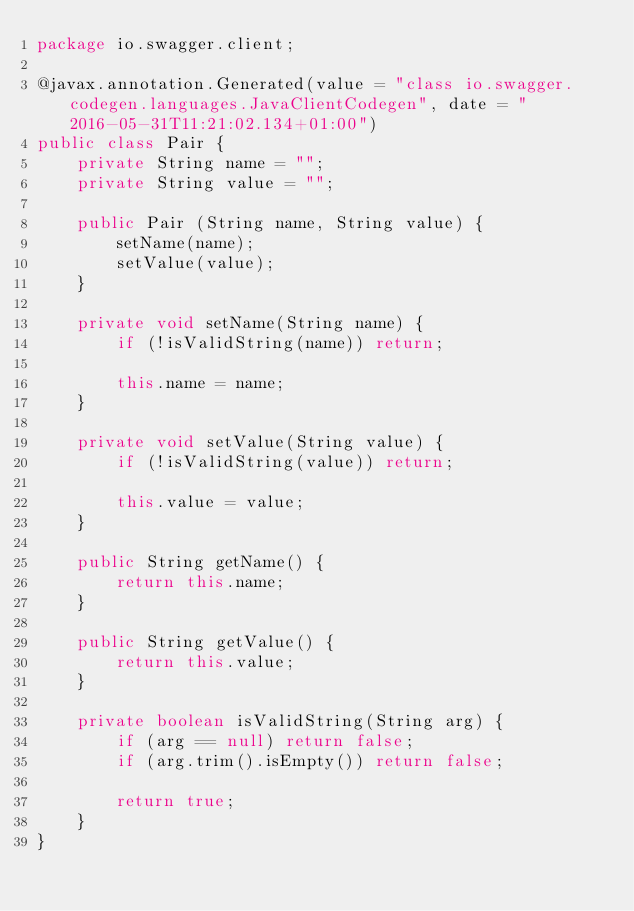<code> <loc_0><loc_0><loc_500><loc_500><_Java_>package io.swagger.client;

@javax.annotation.Generated(value = "class io.swagger.codegen.languages.JavaClientCodegen", date = "2016-05-31T11:21:02.134+01:00")
public class Pair {
    private String name = "";
    private String value = "";

    public Pair (String name, String value) {
        setName(name);
        setValue(value);
    }

    private void setName(String name) {
        if (!isValidString(name)) return;

        this.name = name;
    }

    private void setValue(String value) {
        if (!isValidString(value)) return;

        this.value = value;
    }

    public String getName() {
        return this.name;
    }

    public String getValue() {
        return this.value;
    }

    private boolean isValidString(String arg) {
        if (arg == null) return false;
        if (arg.trim().isEmpty()) return false;

        return true;
    }
}
</code> 